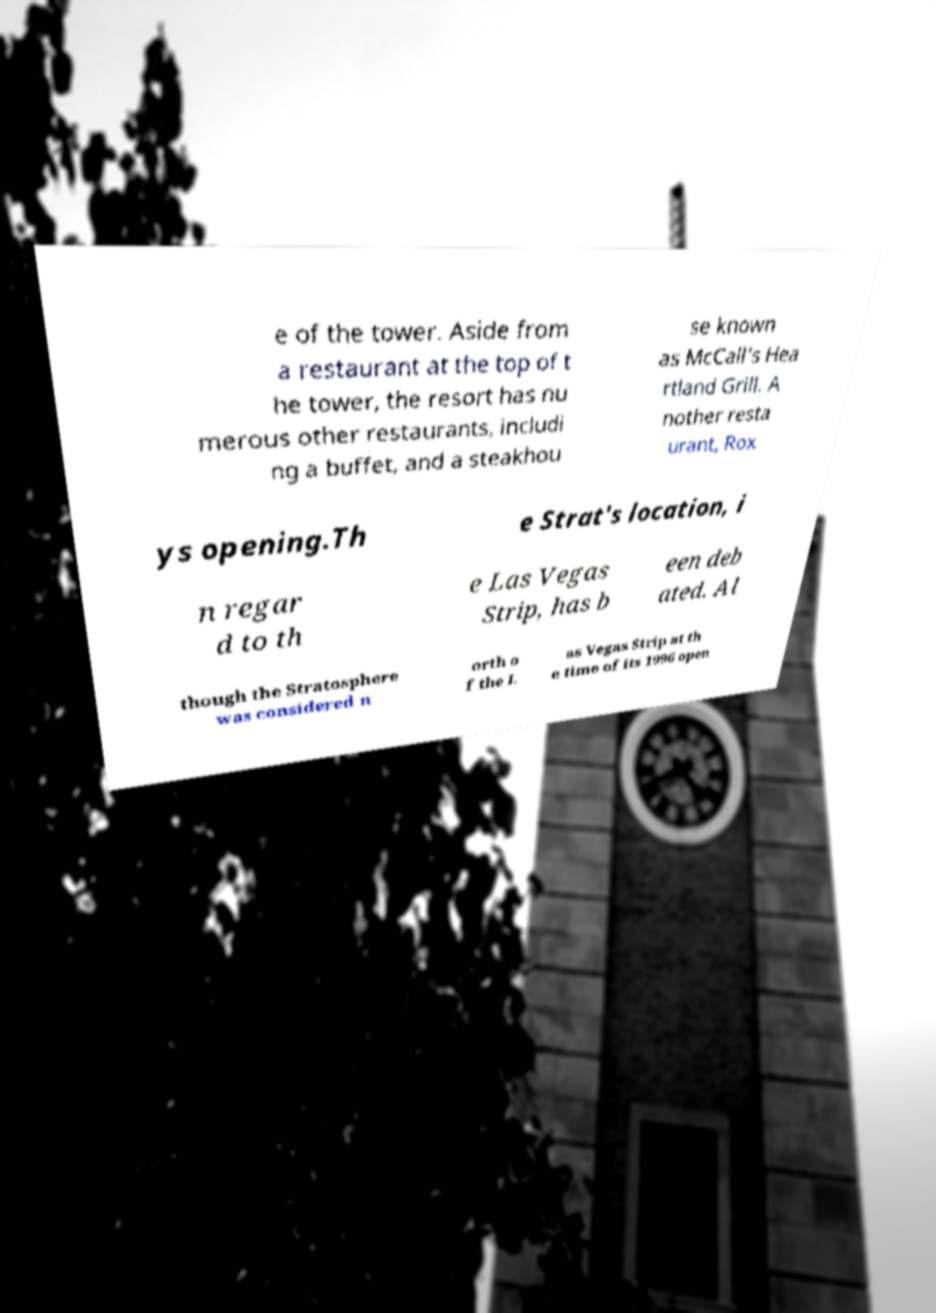For documentation purposes, I need the text within this image transcribed. Could you provide that? e of the tower. Aside from a restaurant at the top of t he tower, the resort has nu merous other restaurants, includi ng a buffet, and a steakhou se known as McCall’s Hea rtland Grill. A nother resta urant, Rox ys opening.Th e Strat's location, i n regar d to th e Las Vegas Strip, has b een deb ated. Al though the Stratosphere was considered n orth o f the L as Vegas Strip at th e time of its 1996 open 